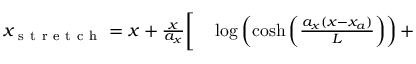Convert formula to latex. <formula><loc_0><loc_0><loc_500><loc_500>\begin{array} { r l } { x _ { s t r e t c h } = x + \frac { x } { a _ { x } } { \Big [ } } & \log \left ( \cosh \left ( \frac { a _ { x } ( x - x _ { a } ) } { L } \right ) \right ) + } \end{array}</formula> 